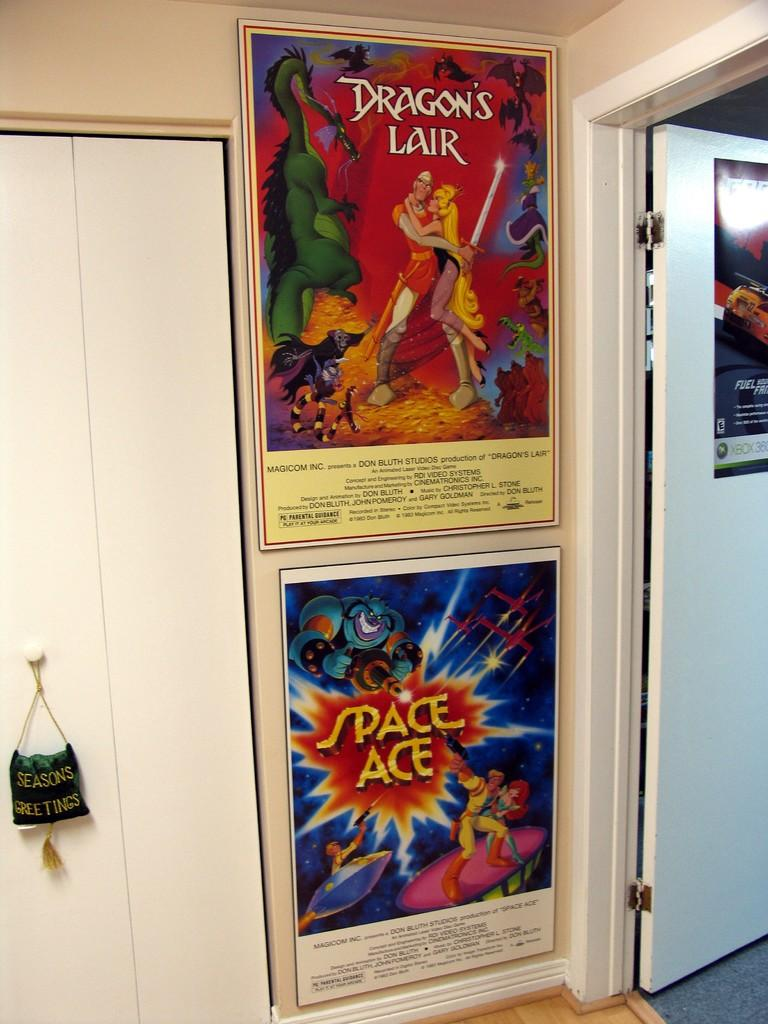<image>
Offer a succinct explanation of the picture presented. the word Dragon's Lair is on the poster above another one 